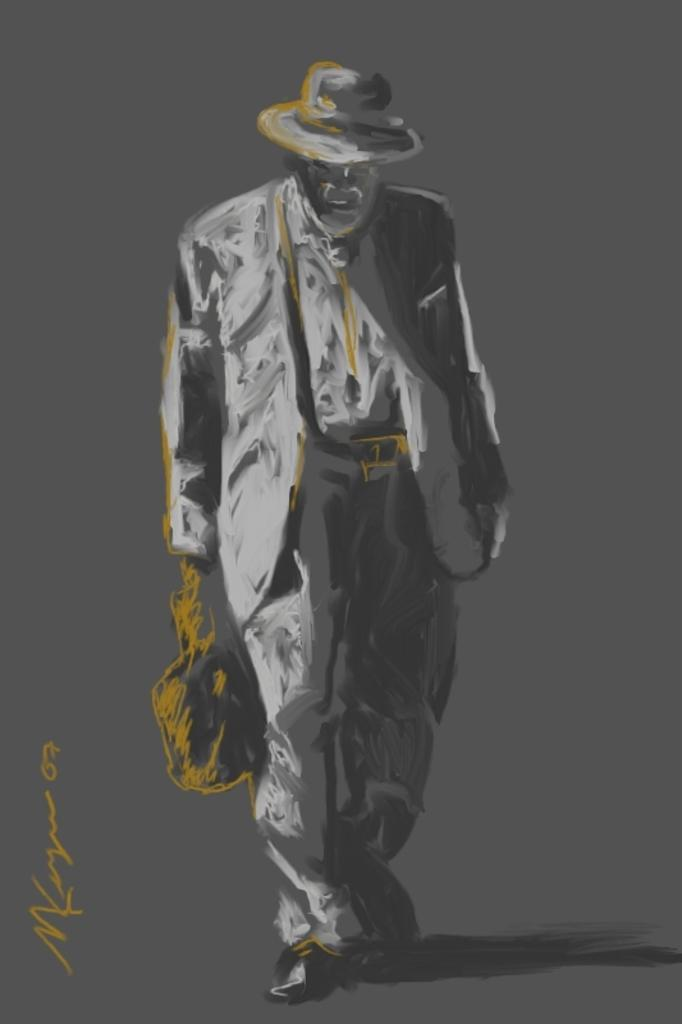What type of artwork is depicted in the image? The image is a painting. Can you describe the main subject of the painting? There is a person in the center of the painting. What is the person holding in the painting? The person is holding a bag. What is the person doing in the painting? The person is walking. Are there any words or letters in the painting? Yes, there is text in the painting. What type of meat is being served in the painting? There is no meat present in the painting; it features a person walking with a bag and text. 